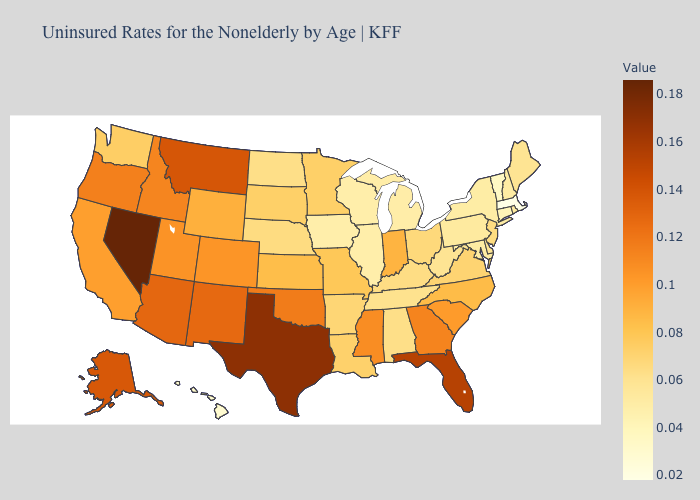Among the states that border California , which have the lowest value?
Keep it brief. Oregon. Does Massachusetts have the lowest value in the Northeast?
Concise answer only. Yes. Does Georgia have the highest value in the USA?
Write a very short answer. No. Does New Mexico have a higher value than Indiana?
Give a very brief answer. Yes. Which states have the lowest value in the USA?
Concise answer only. Massachusetts. Which states have the lowest value in the USA?
Concise answer only. Massachusetts. 